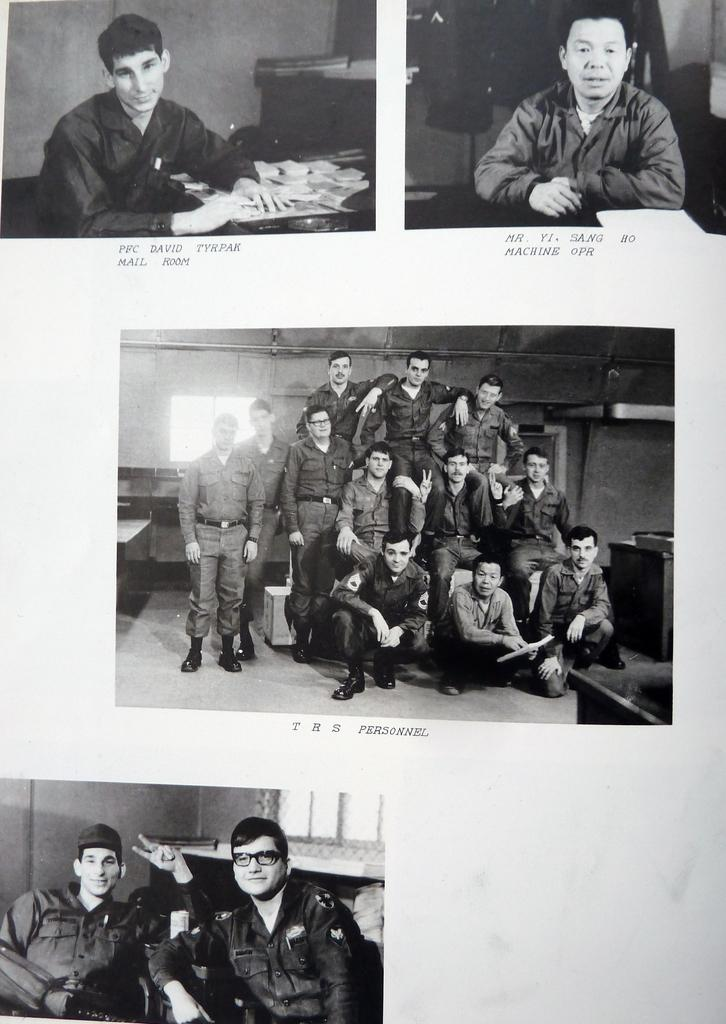What is the main subject of the picture? The main subject of the picture is a collage of images. Can you describe the collage in more detail? Unfortunately, the facts provided do not give any specific details about the images in the collage. What is written below the collage? There is text written below the collage. How many bikes are parked next to the desk in the image? There are no bikes or desks present in the image; it features a collage of images and text. 